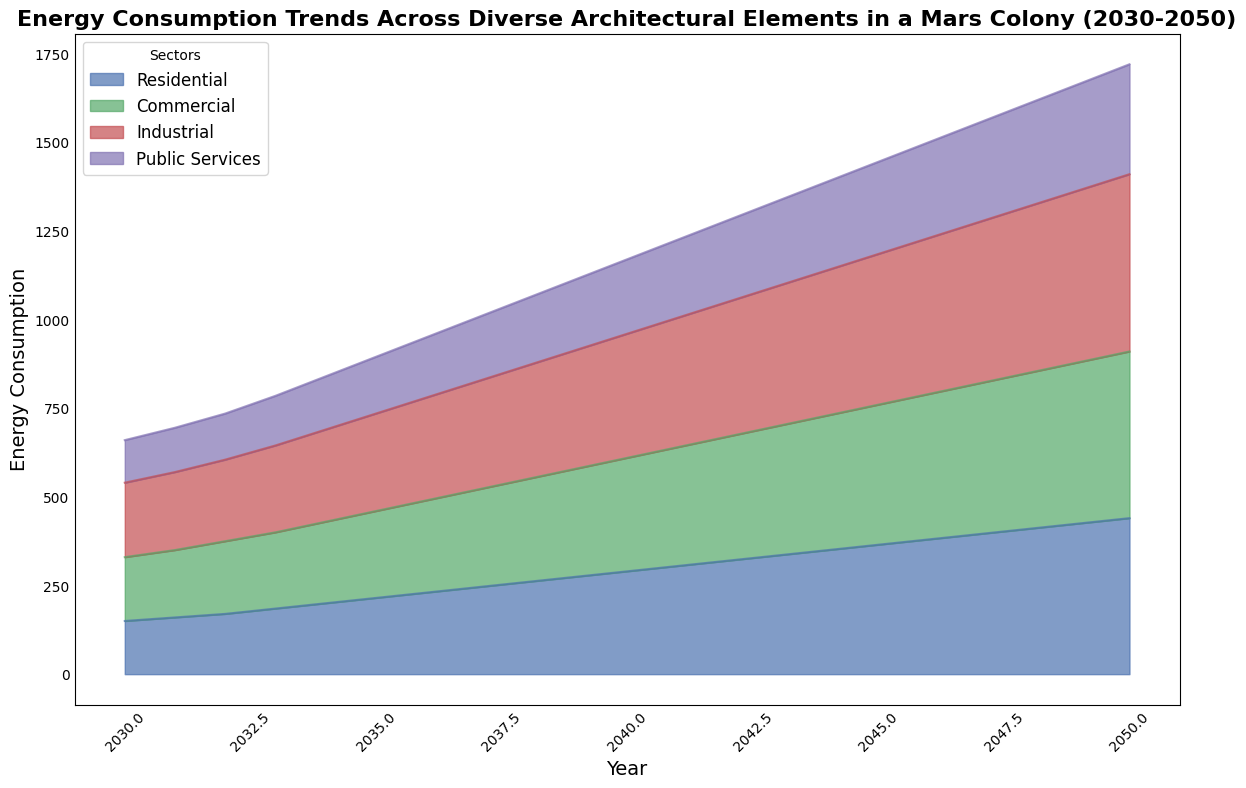What sector consumes the most energy in 2035? Look at the year 2035 and compare the heights (or areas) of each sector. The Industrial sector has the highest value at 275 units.
Answer: Industrial How did the total energy consumption change from 2030 to 2050? Note the total energy consumption for the years 2030 and 2050: 660 units and 1720 units respectively. The difference is 1720 - 660 = 1060 units.
Answer: Increased by 1060 units What is the average energy consumption of the Commercial sector from 2040 to 2050? Sum the energy consumption of the Commercial sector from 2040 to 2050 and divide by the number of years. (320+335+350+365+380+395+410+425+440+455+470)/11 = 3823/11 = 347.55
Answer: 347.55 units Which sector showed the second highest increase in consumption from 2030 to 2050? Calculate the difference in consumption for each sector from 2030 to 2050: Residential (440-150), Commercial (470-180), Industrial (500-210), Public Services (310-120). The differences are 290, 290, 290, and 190 units respectively. The second highest increase is tied between Residential, Commercial, and Industrial at 290 units.
Answer: Residential, Commercial, and Industrial In which year did the Public Services sector consume 200 units of energy? Scan through the years to find when the Public Services sector reaches 200 units. This occurs in the year 2039.
Answer: 2039 By how much did the energy consumption in the Residential sector increase from 2036 to 2041? Note the values for the Residential sector in 2036 and 2041: 230 units and 305 units respectively. The difference is 305 - 230 = 75 units.
Answer: 75 units Which sector had the smallest proportion of energy consumption in 2042? Compare the heights (or areas) of the sectors in 2042. Public Services had the smallest proportion at 230 units.
Answer: Public Services In which year did the total energy consumption first exceed 1000 units? Look at the total energy consumption across the years. The total first exceeds 1000 units in 2037 when it reaches 1005 units.
Answer: 2037 What was the trend of energy consumption in the Industrial sector from 2030 to 2050? Observe the trend line for the Industrial sector. It consistently increases from 210 units in 2030 to 500 units in 2050.
Answer: Increasing consistently Compare the energy consumption in the Commercial sector in 2035 with that of the Industrial sector in 2040. Which one is higher? Note the values for the Commercial sector in 2035 and the Industrial sector in 2040: 245 units and 350 units respectively. The Industrial sector in 2040 is higher.
Answer: Industrial sector in 2040 